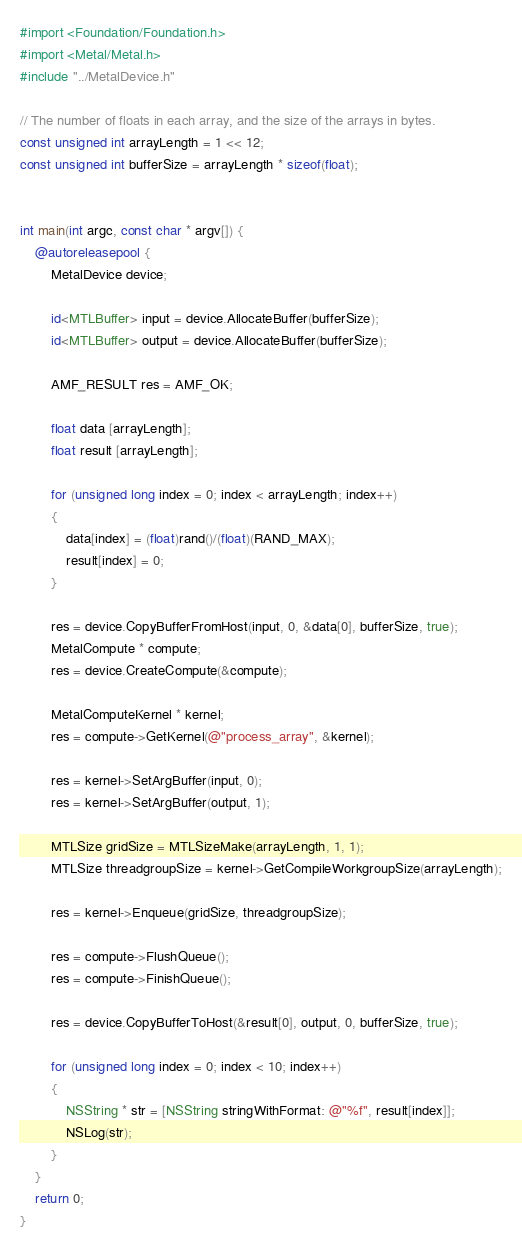<code> <loc_0><loc_0><loc_500><loc_500><_ObjectiveC_>#import <Foundation/Foundation.h>
#import <Metal/Metal.h>
#include "../MetalDevice.h"

// The number of floats in each array, and the size of the arrays in bytes.
const unsigned int arrayLength = 1 << 12;
const unsigned int bufferSize = arrayLength * sizeof(float);


int main(int argc, const char * argv[]) {
    @autoreleasepool {
        MetalDevice device;

        id<MTLBuffer> input = device.AllocateBuffer(bufferSize);
        id<MTLBuffer> output = device.AllocateBuffer(bufferSize);

        AMF_RESULT res = AMF_OK;

        float data [arrayLength];
        float result [arrayLength];

        for (unsigned long index = 0; index < arrayLength; index++)
        {
            data[index] = (float)rand()/(float)(RAND_MAX);
            result[index] = 0;
        }

        res = device.CopyBufferFromHost(input, 0, &data[0], bufferSize, true);
        MetalCompute * compute;
        res = device.CreateCompute(&compute);

        MetalComputeKernel * kernel;
        res = compute->GetKernel(@"process_array", &kernel);

        res = kernel->SetArgBuffer(input, 0);
        res = kernel->SetArgBuffer(output, 1);

        MTLSize gridSize = MTLSizeMake(arrayLength, 1, 1);
        MTLSize threadgroupSize = kernel->GetCompileWorkgroupSize(arrayLength);

        res = kernel->Enqueue(gridSize, threadgroupSize);

        res = compute->FlushQueue();
        res = compute->FinishQueue();

        res = device.CopyBufferToHost(&result[0], output, 0, bufferSize, true);

        for (unsigned long index = 0; index < 10; index++)
        {
            NSString * str = [NSString stringWithFormat: @"%f", result[index]];
            NSLog(str);
        }
    }
    return 0;
}
</code> 